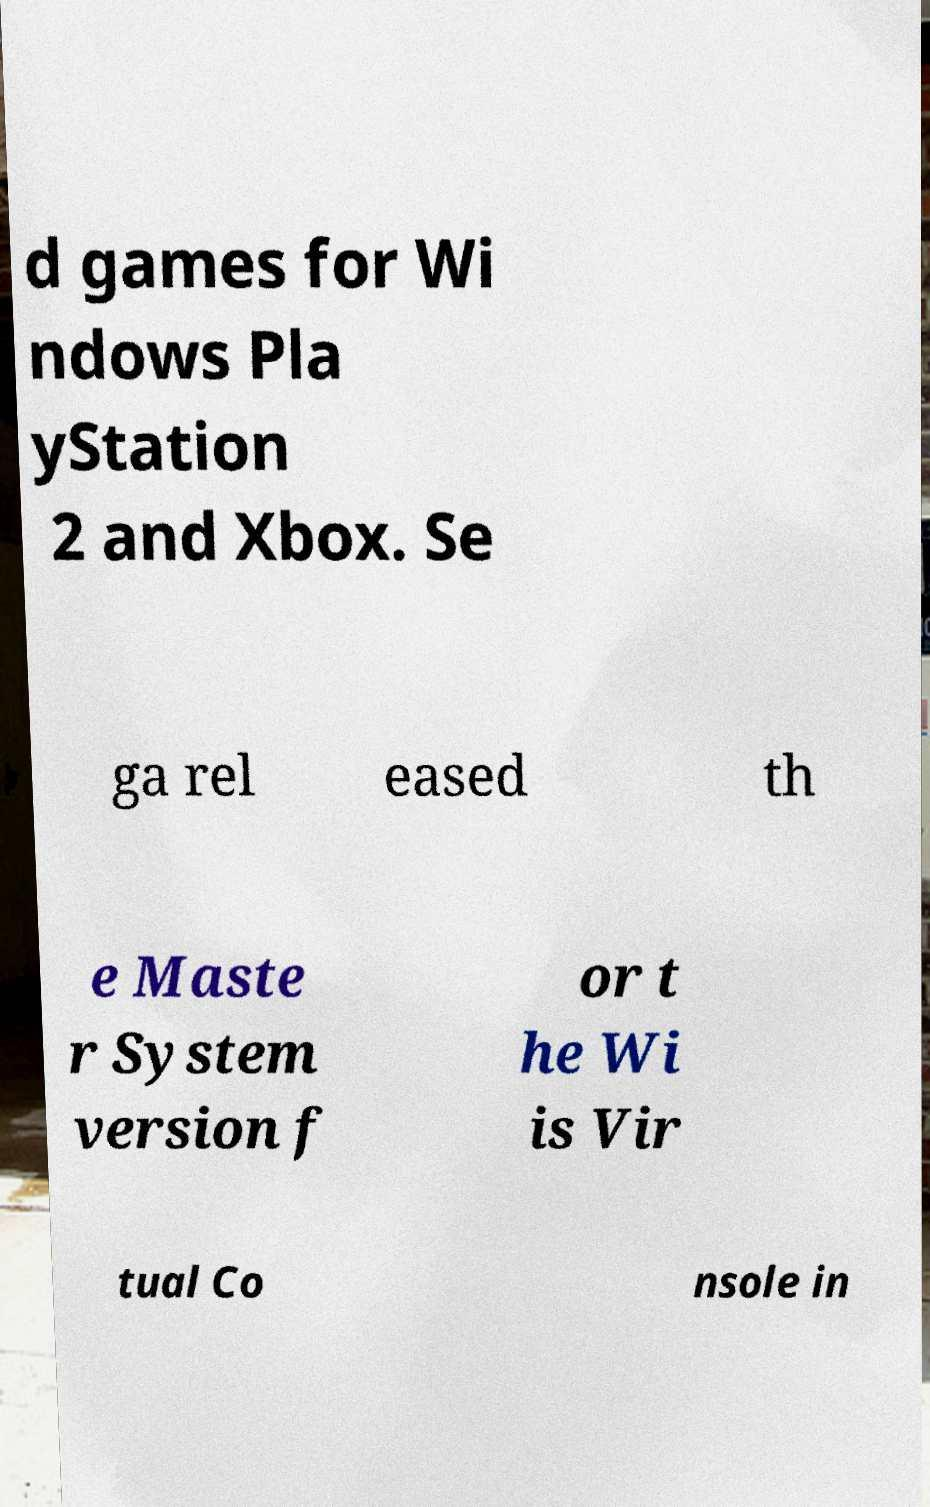Can you read and provide the text displayed in the image?This photo seems to have some interesting text. Can you extract and type it out for me? d games for Wi ndows Pla yStation 2 and Xbox. Se ga rel eased th e Maste r System version f or t he Wi is Vir tual Co nsole in 